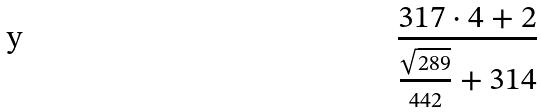Convert formula to latex. <formula><loc_0><loc_0><loc_500><loc_500>\frac { 3 1 7 \cdot 4 + 2 } { \frac { \sqrt { 2 8 9 } } { 4 4 2 } + 3 1 4 }</formula> 